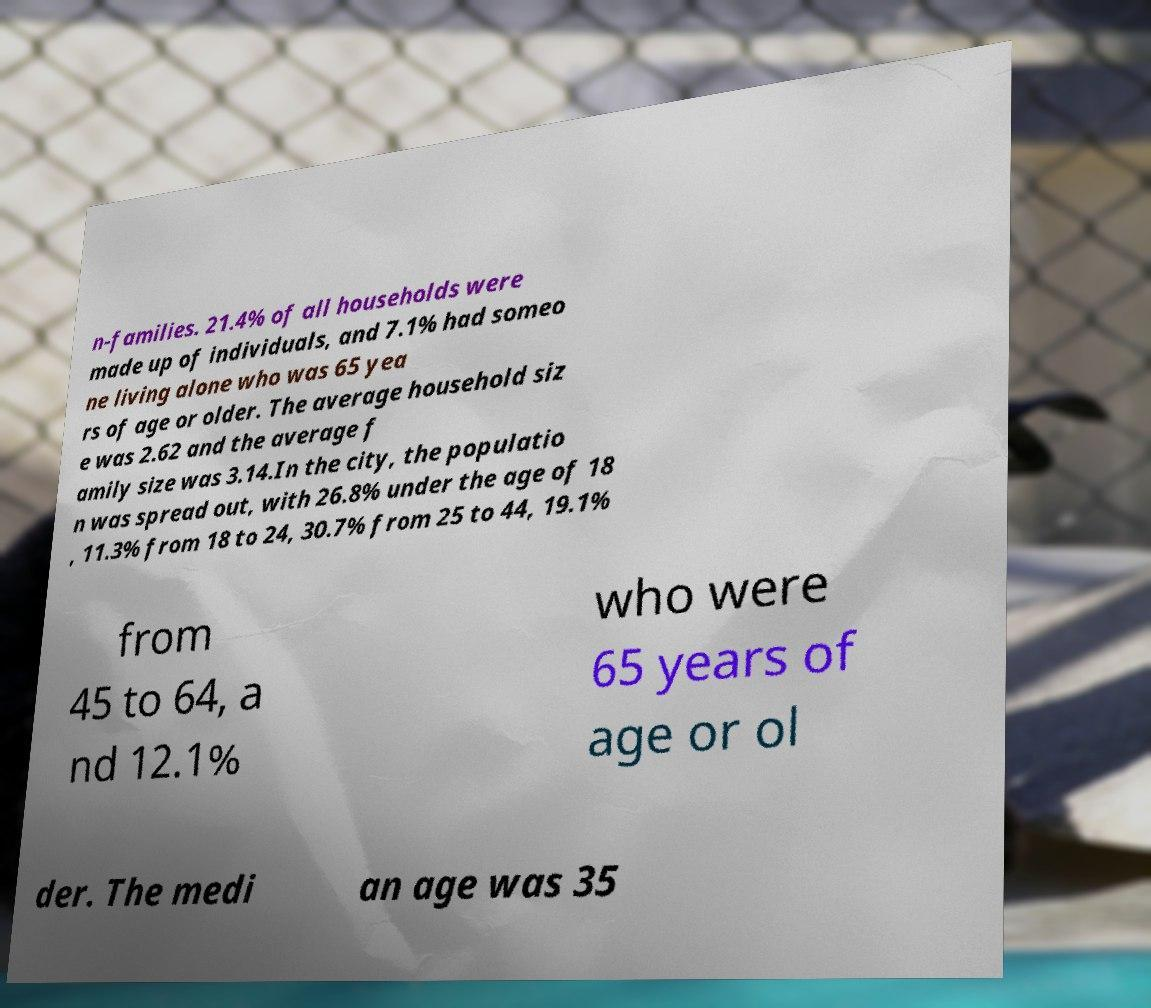For documentation purposes, I need the text within this image transcribed. Could you provide that? n-families. 21.4% of all households were made up of individuals, and 7.1% had someo ne living alone who was 65 yea rs of age or older. The average household siz e was 2.62 and the average f amily size was 3.14.In the city, the populatio n was spread out, with 26.8% under the age of 18 , 11.3% from 18 to 24, 30.7% from 25 to 44, 19.1% from 45 to 64, a nd 12.1% who were 65 years of age or ol der. The medi an age was 35 